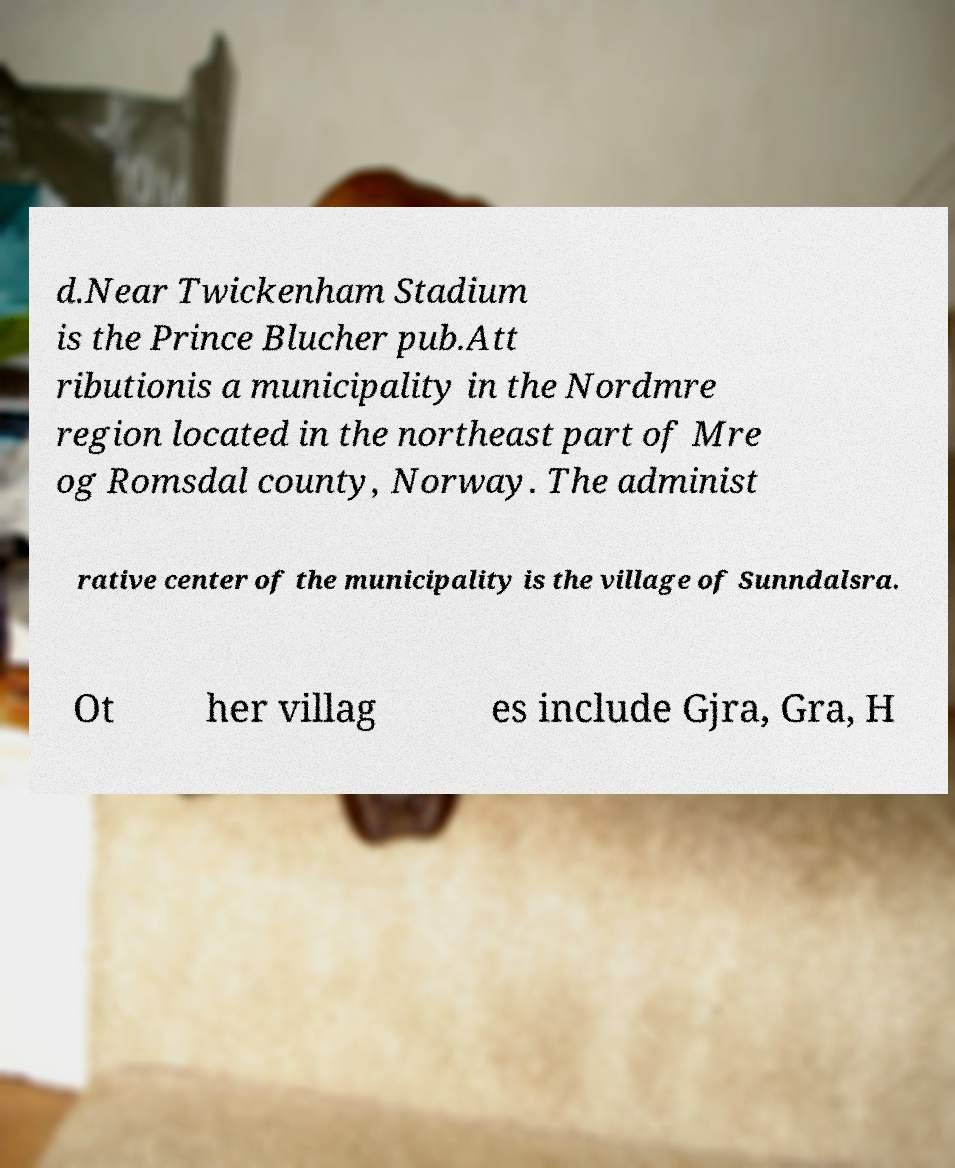I need the written content from this picture converted into text. Can you do that? d.Near Twickenham Stadium is the Prince Blucher pub.Att ributionis a municipality in the Nordmre region located in the northeast part of Mre og Romsdal county, Norway. The administ rative center of the municipality is the village of Sunndalsra. Ot her villag es include Gjra, Gra, H 